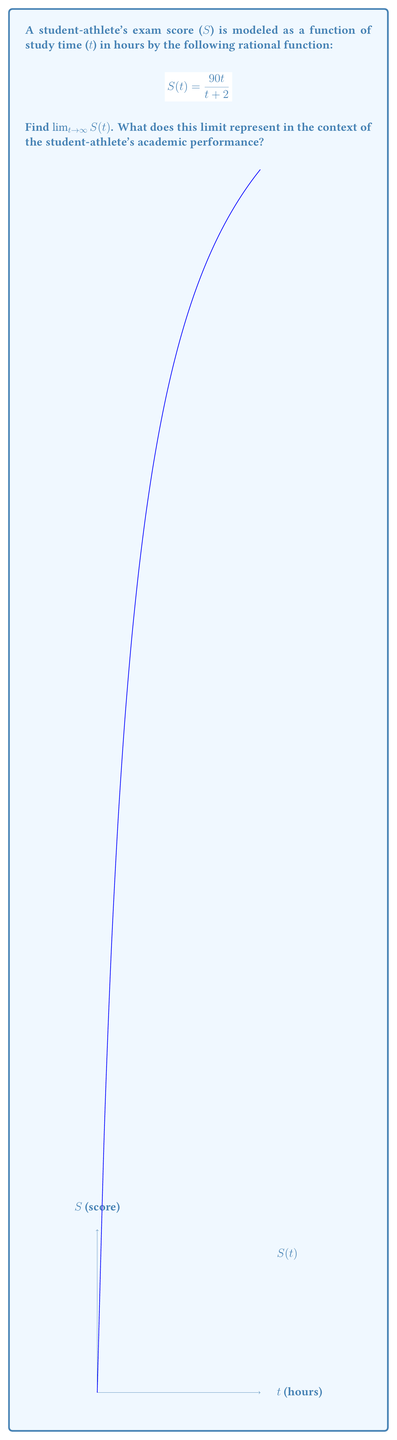Help me with this question. To find the limit of $S(t)$ as $t$ approaches infinity, we can follow these steps:

1) First, let's examine the behavior of the function as $t$ gets very large:

   $$\lim_{t \to \infty} S(t) = \lim_{t \to \infty} \frac{90t}{t + 2}$$

2) Both the numerator and denominator approach infinity as $t$ approaches infinity. This is an indeterminate form of type $\frac{\infty}{\infty}$.

3) To resolve this, we can divide both the numerator and denominator by the highest power of $t$ in the denominator, which is $t$:

   $$\lim_{t \to \infty} \frac{90t}{t + 2} = \lim_{t \to \infty} \frac{90t/t}{(t + 2)/t} = \lim_{t \to \infty} \frac{90}{1 + 2/t}$$

4) As $t$ approaches infinity, $2/t$ approaches 0:

   $$\lim_{t \to \infty} \frac{90}{1 + 2/t} = \frac{90}{1 + 0} = 90$$

5) Therefore, the limit of $S(t)$ as $t$ approaches infinity is 90.

In the context of the student-athlete's academic performance, this limit represents the maximum possible exam score that can be achieved, regardless of how many hours are spent studying. It suggests that there's a theoretical cap on the exam score at 90 points, even with infinite study time.
Answer: 90 